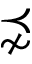Convert formula to latex. <formula><loc_0><loc_0><loc_500><loc_500>\precnsim</formula> 